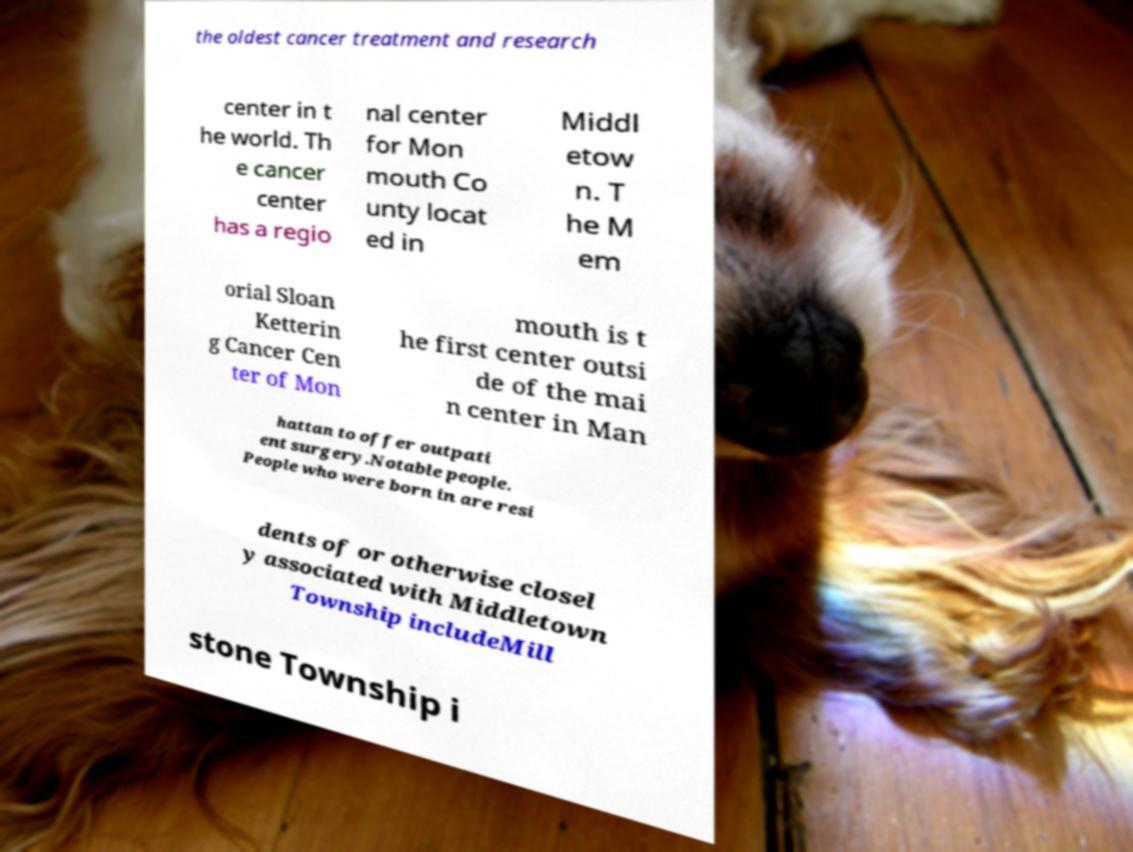What messages or text are displayed in this image? I need them in a readable, typed format. the oldest cancer treatment and research center in t he world. Th e cancer center has a regio nal center for Mon mouth Co unty locat ed in Middl etow n. T he M em orial Sloan Ketterin g Cancer Cen ter of Mon mouth is t he first center outsi de of the mai n center in Man hattan to offer outpati ent surgery.Notable people. People who were born in are resi dents of or otherwise closel y associated with Middletown Township includeMill stone Township i 